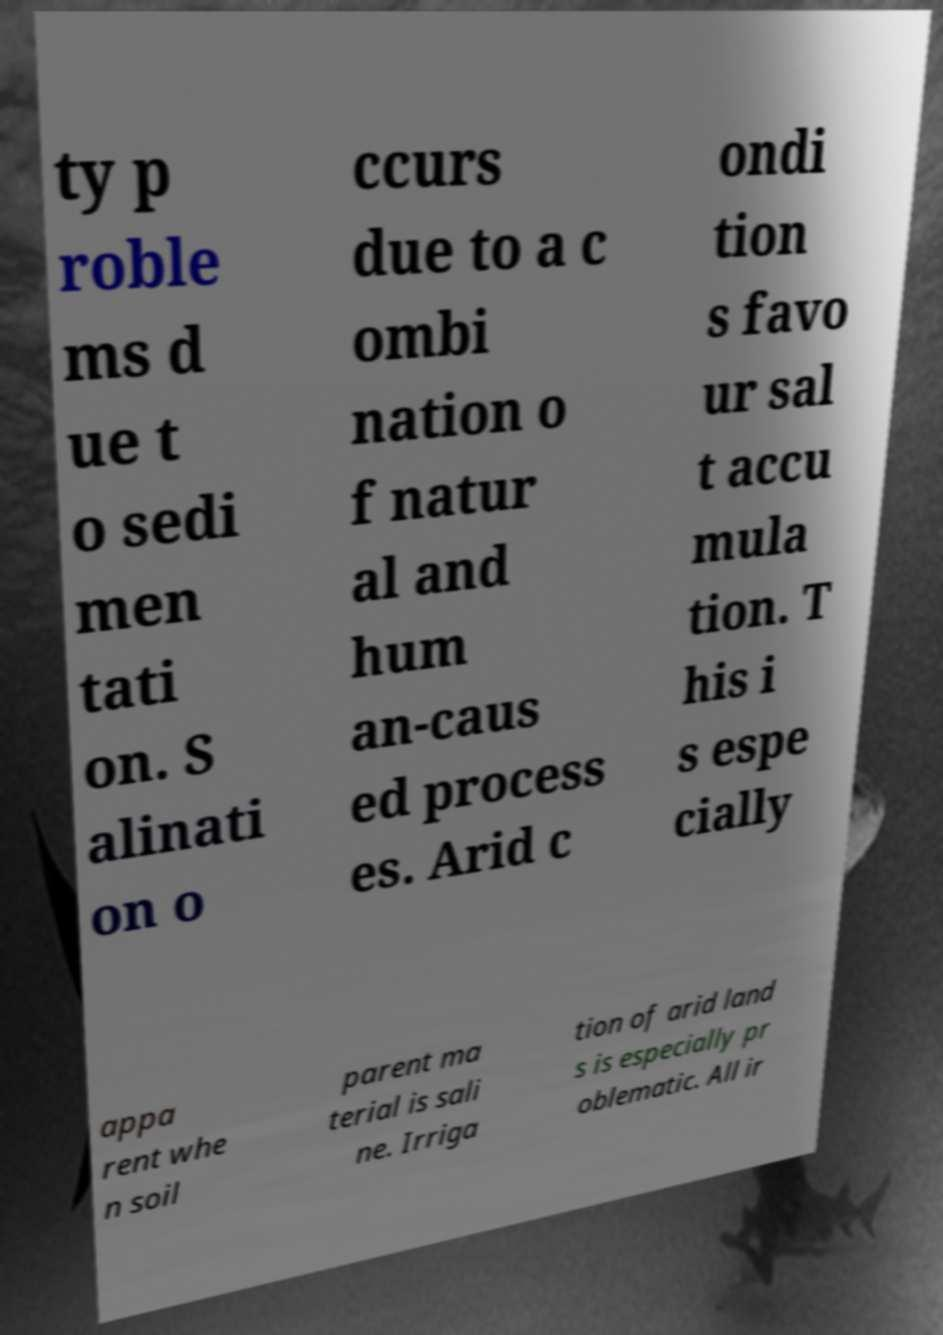Could you assist in decoding the text presented in this image and type it out clearly? ty p roble ms d ue t o sedi men tati on. S alinati on o ccurs due to a c ombi nation o f natur al and hum an-caus ed process es. Arid c ondi tion s favo ur sal t accu mula tion. T his i s espe cially appa rent whe n soil parent ma terial is sali ne. Irriga tion of arid land s is especially pr oblematic. All ir 